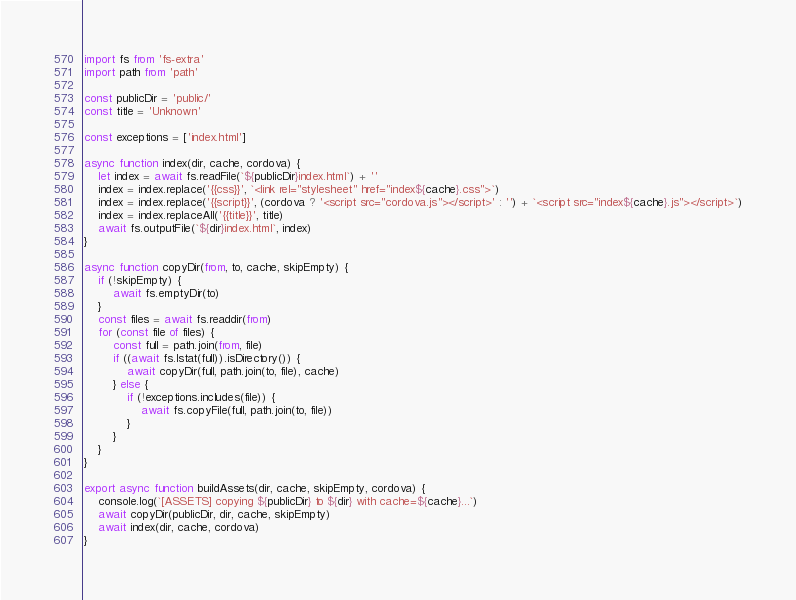Convert code to text. <code><loc_0><loc_0><loc_500><loc_500><_JavaScript_>import fs from 'fs-extra'
import path from 'path'

const publicDir = 'public/'
const title = 'Unknown'

const exceptions = ['index.html']

async function index(dir, cache, cordova) {
    let index = await fs.readFile(`${publicDir}index.html`) + ''
    index = index.replace('{{css}}', `<link rel="stylesheet" href="index${cache}.css">`)
    index = index.replace('{{script}}', (cordova ? '<script src="cordova.js"></script>' : '') + `<script src="index${cache}.js"></script>`)
    index = index.replaceAll('{{title}}', title)
    await fs.outputFile(`${dir}index.html`, index)
}

async function copyDir(from, to, cache, skipEmpty) {
    if (!skipEmpty) {
        await fs.emptyDir(to)
    }
    const files = await fs.readdir(from)
    for (const file of files) {
        const full = path.join(from, file)
        if ((await fs.lstat(full)).isDirectory()) {
            await copyDir(full, path.join(to, file), cache)
        } else {
            if (!exceptions.includes(file)) {
                await fs.copyFile(full, path.join(to, file))
            }
        }
    }
}

export async function buildAssets(dir, cache, skipEmpty, cordova) {
    console.log(`[ASSETS] copying ${publicDir} to ${dir} with cache=${cache}...`)
    await copyDir(publicDir, dir, cache, skipEmpty)
    await index(dir, cache, cordova)
}
</code> 